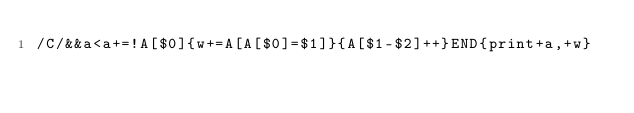<code> <loc_0><loc_0><loc_500><loc_500><_Awk_>/C/&&a<a+=!A[$0]{w+=A[A[$0]=$1]}{A[$1-$2]++}END{print+a,+w}</code> 